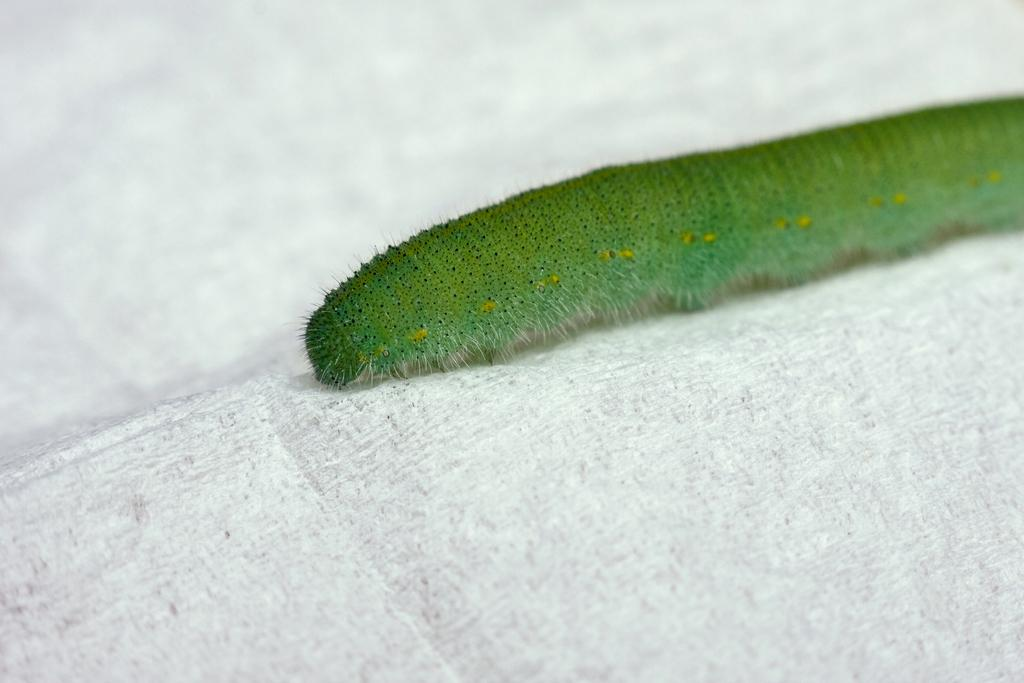What type of insect is in the image? There is a green color insect in the image. What is the insect resting on? The insect is on a white color object. What type of fruit is being compared to the insect in the image? There is no fruit present in the image, nor is there any comparison being made between the insect and a fruit. 